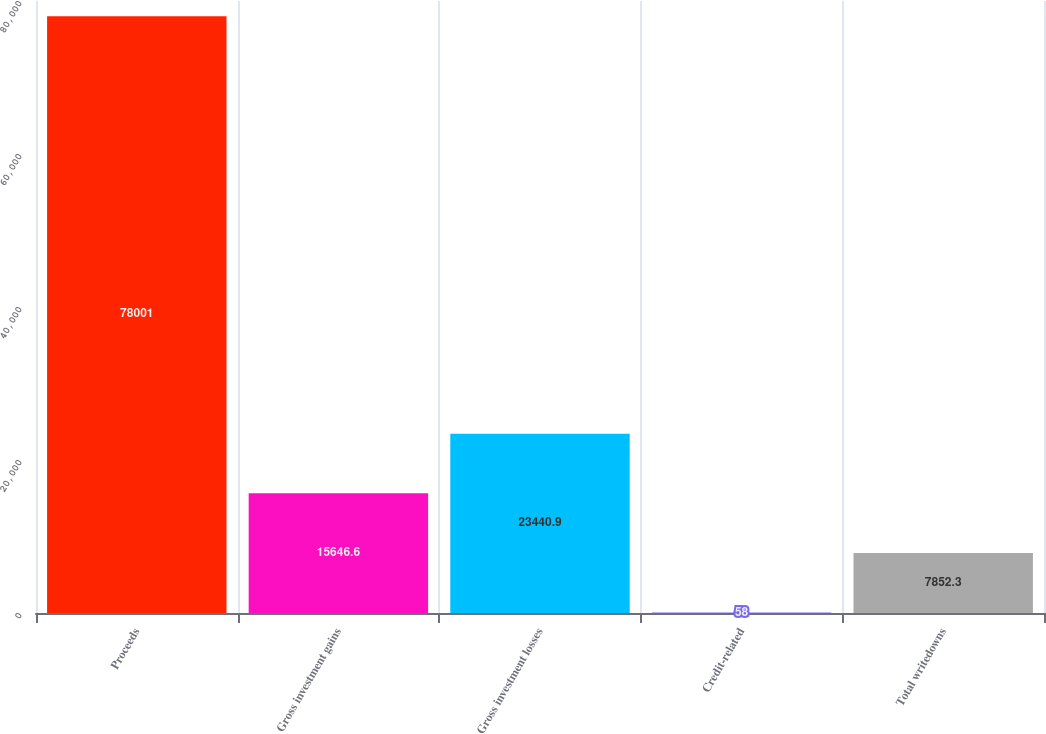Convert chart. <chart><loc_0><loc_0><loc_500><loc_500><bar_chart><fcel>Proceeds<fcel>Gross investment gains<fcel>Gross investment losses<fcel>Credit-related<fcel>Total writedowns<nl><fcel>78001<fcel>15646.6<fcel>23440.9<fcel>58<fcel>7852.3<nl></chart> 